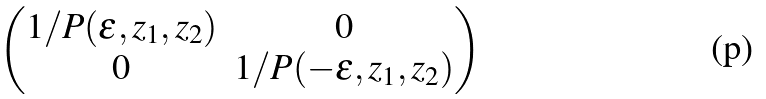Convert formula to latex. <formula><loc_0><loc_0><loc_500><loc_500>\begin{pmatrix} 1 / P ( \varepsilon , z _ { 1 } , z _ { 2 } ) & 0 \\ 0 & 1 / P ( - \varepsilon , z _ { 1 } , z _ { 2 } ) \\ \end{pmatrix}</formula> 